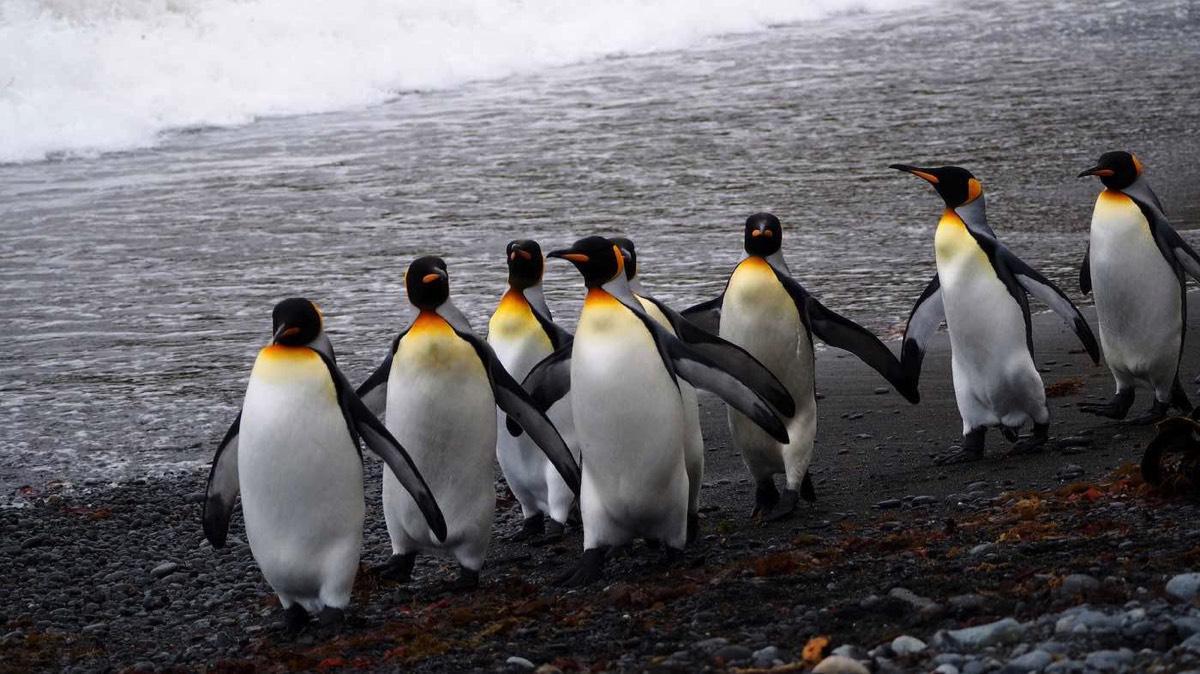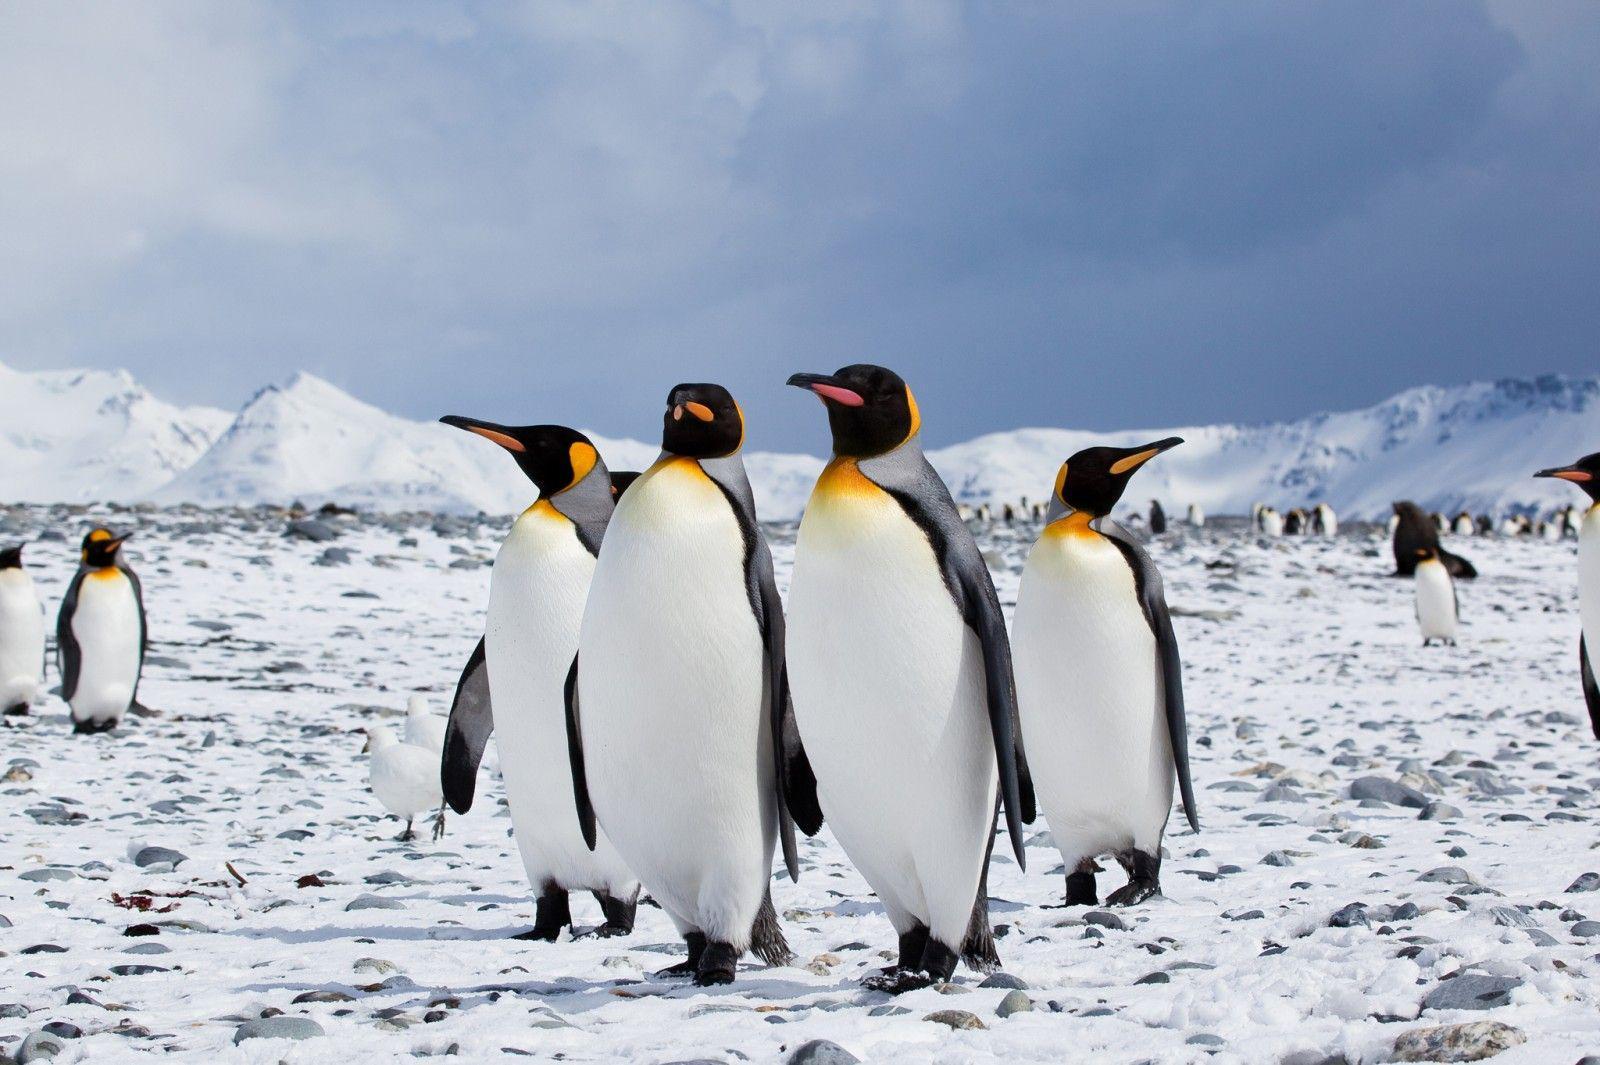The first image is the image on the left, the second image is the image on the right. Evaluate the accuracy of this statement regarding the images: "An image shows a row of no more than six upright penguins, all facing right.". Is it true? Answer yes or no. No. The first image is the image on the left, the second image is the image on the right. Considering the images on both sides, is "The penguins in the image on the right are walking across the snow." valid? Answer yes or no. Yes. The first image is the image on the left, the second image is the image on the right. Examine the images to the left and right. Is the description "There are five penguins" accurate? Answer yes or no. No. 